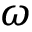<formula> <loc_0><loc_0><loc_500><loc_500>\omega</formula> 